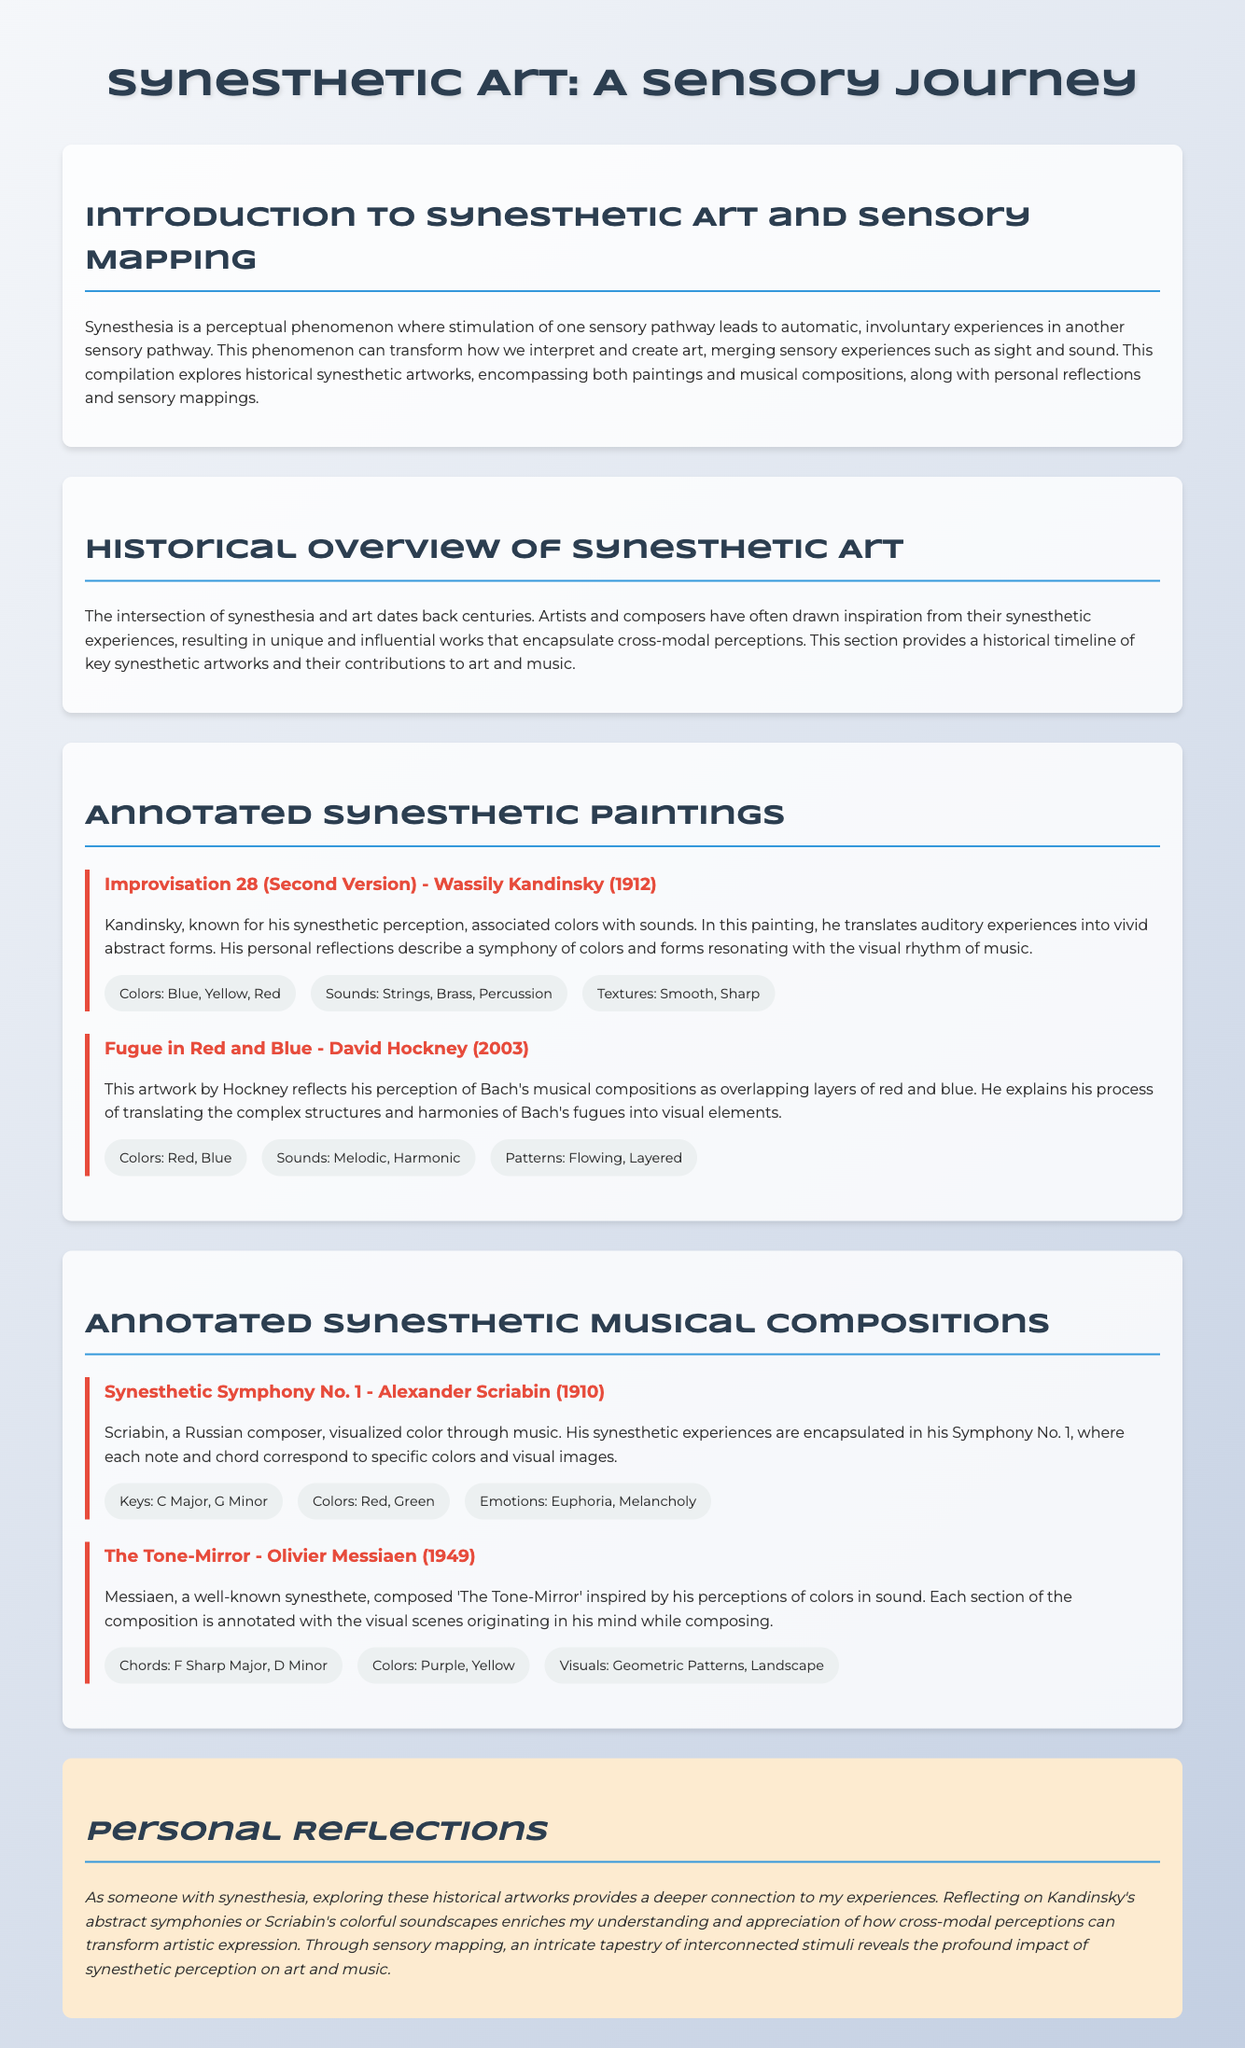What is the title of the document? The title is prominently displayed at the top of the document, stating, "Synesthetic Art: A Sensory Journey."
Answer: Synesthetic Art: A Sensory Journey Who painted "Improvisation 28 (Second Version)"? The document provides the name of the artist associated with this painting, which is Wassily Kandinsky.
Answer: Wassily Kandinsky In what year was "Fugue in Red and Blue" created? The year of creation is specified in the document as 2003 for this artwork.
Answer: 2003 What colors are associated with Scriabin's Symphony No. 1? The sensory mapping section for this composition lists the corresponding colors, which are Red and Green.
Answer: Red, Green What is the primary emotion associated with "The Tone-Mirror"? The document mentions the emotions tied to this composition, specifically noting Melancholy.
Answer: Melancholy What sensory mapping type is included for each artwork? Each artwork includes sensory mapping elements, specifically detailing colors, sounds, and patterns.
Answer: Colors, Sounds, Patterns How does the personal reflection section describe the impact of synesthetic art? The reflection describes the deeper connection and enrichment of understanding through exploration.
Answer: Deeper connection, enrichment of understanding What is the relationship explored in the document? The document discusses the relationship between sensory experiences and artistic expression in synesthesia.
Answer: Sensory experiences and artistic expression 